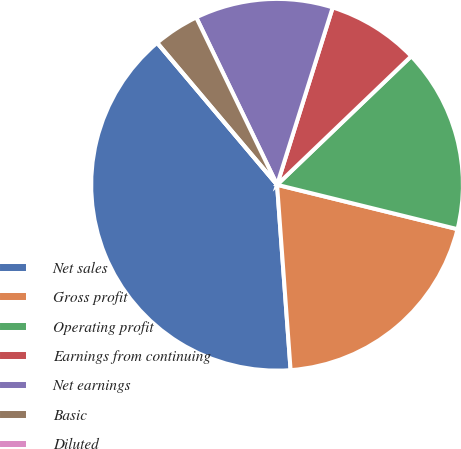Convert chart. <chart><loc_0><loc_0><loc_500><loc_500><pie_chart><fcel>Net sales<fcel>Gross profit<fcel>Operating profit<fcel>Earnings from continuing<fcel>Net earnings<fcel>Basic<fcel>Diluted<nl><fcel>40.0%<fcel>20.0%<fcel>16.0%<fcel>8.0%<fcel>12.0%<fcel>4.0%<fcel>0.0%<nl></chart> 